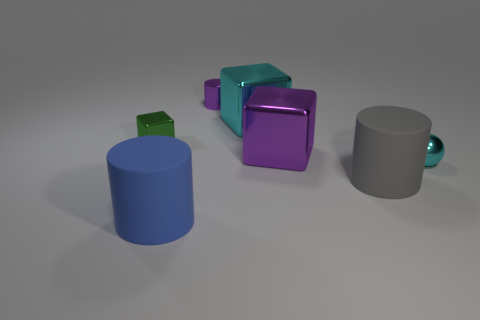What is the color of the small metallic block?
Your answer should be very brief. Green. Are there more cylinders left of the big cyan metal block than blocks that are right of the green metal thing?
Provide a short and direct response. No. What color is the big matte cylinder behind the blue cylinder?
Your answer should be compact. Gray. Do the purple object that is on the right side of the tiny cylinder and the matte cylinder that is behind the large blue object have the same size?
Make the answer very short. Yes. What number of things are big blocks or gray matte cylinders?
Provide a succinct answer. 3. What material is the purple object behind the cyan shiny object that is behind the small cyan ball?
Keep it short and to the point. Metal. How many cyan metallic objects have the same shape as the tiny green object?
Your response must be concise. 1. Are there any things of the same color as the metal cylinder?
Provide a short and direct response. Yes. How many objects are either big shiny cubes in front of the purple cylinder or large objects that are on the right side of the purple metal block?
Provide a succinct answer. 3. There is a metallic cube on the left side of the large blue matte cylinder; are there any shiny things in front of it?
Offer a very short reply. Yes. 